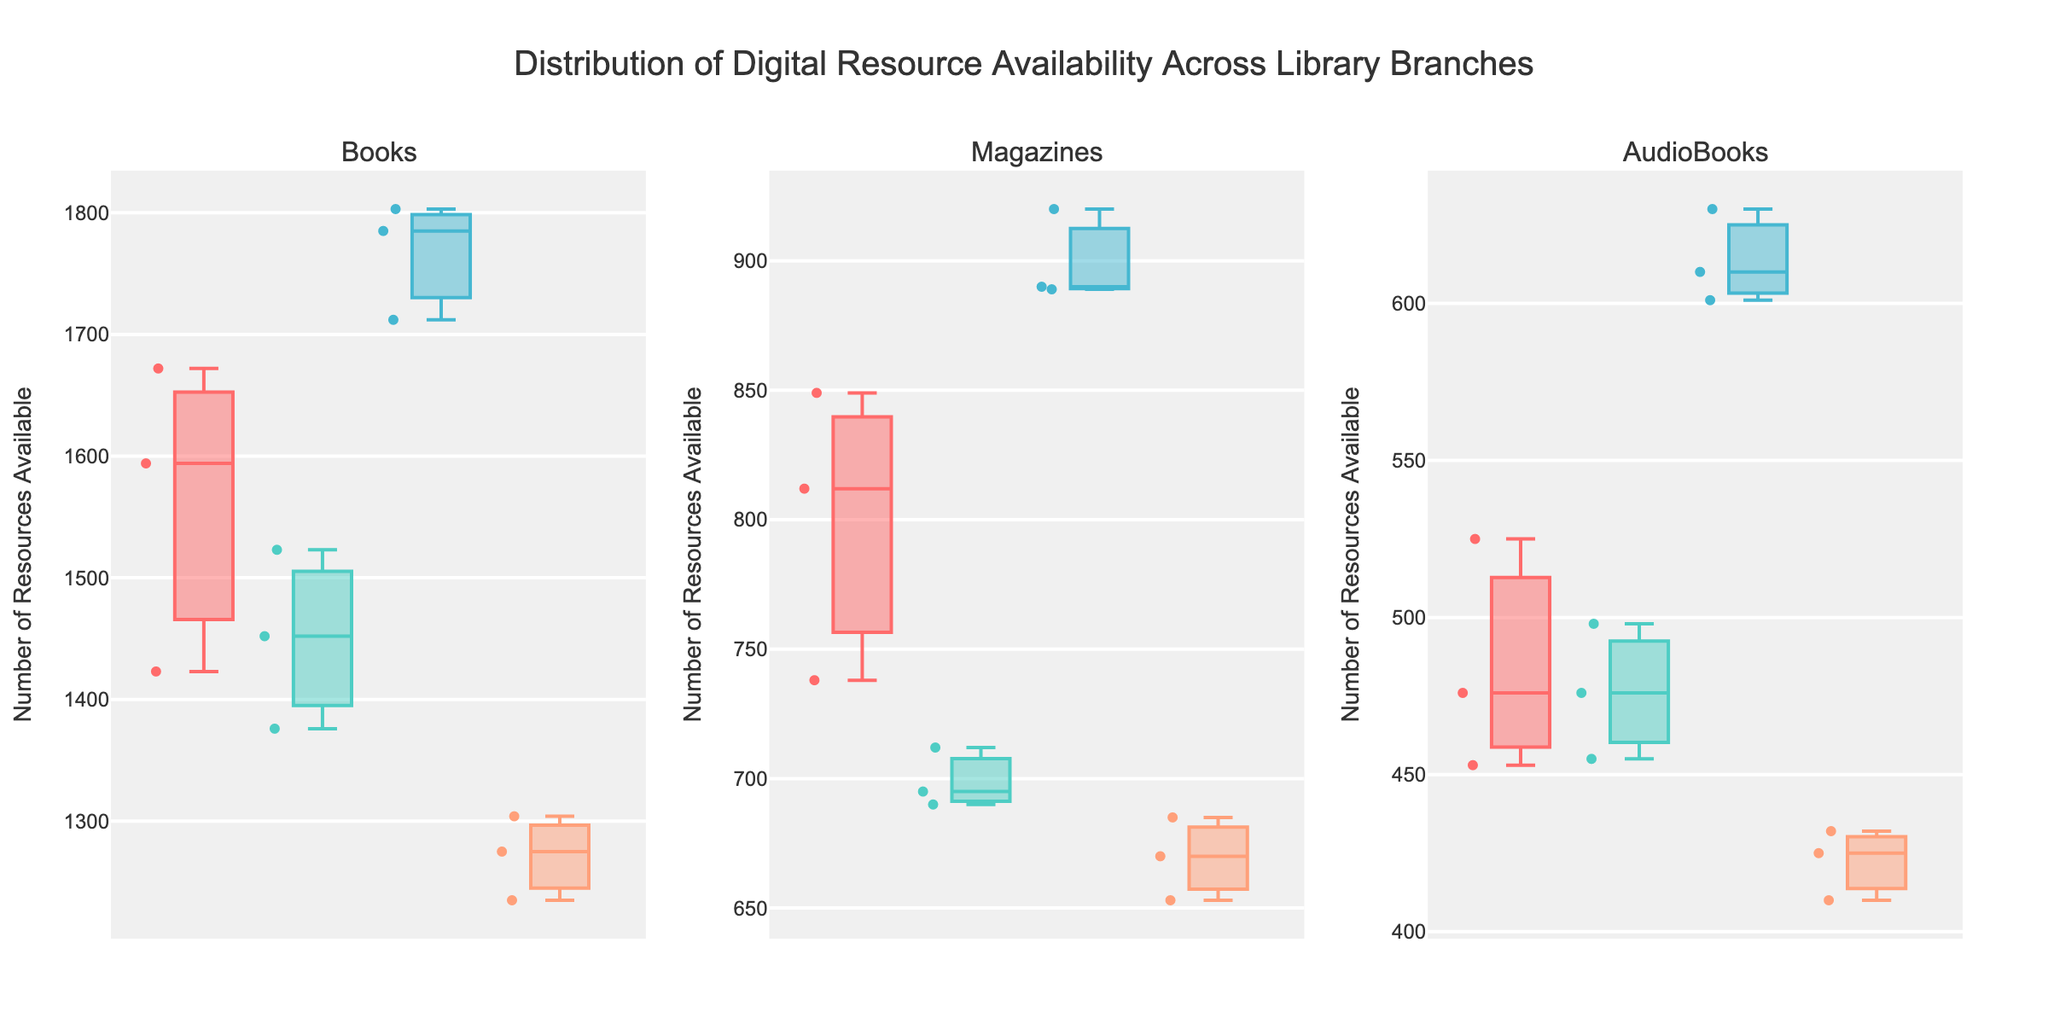What is the highest resource availability for books at the Downtown branch? Look at the Downtown branch's box plot in the "Books" subplot. The highest point is the maximum value of resource availability.
Answer: 1672 What is the median number of available magazines in the Uptown branch? Locate the Uptown branch in the "Magazines" subplot. The median is indicated by the line inside the box plot.
Answer: 695 Which branch has the widest range of audiobook availability? Compare the lengths of the whiskers in the "AudioBooks" subplot for each branch. The branch with the widest range has the longest whiskers.
Answer: Central Which branch has the highest median resource availability for books? Look at the line inside the boxes in the "Books" subplot. The tallest line represents the highest median value.
Answer: Central Compare the interquartile range (IQR) of magazines available between the Downtown and Eastside branches. Which branch has a larger IQR? The IQR is the height of the box. Compare the boxes in the "Magazines" subplot for Downtown and Eastside.
Answer: Downtown What can be inferred about resource availability variation for audiobooks in the Uptown branch compared to the Eastside branch? Look at the "AudioBooks" subplot. Compare the spread and distribution of the box plots for Uptown and Eastside. Uptown has a narrower spread indicating less variation.
Answer: Uptown has less variation Which branch's magazines have the smallest variability in availability? Compare the spread of the box plots in the "Magazines" subplot. The smallest spread represents the smallest variability.
Answer: Eastside What is the difference in the maximum resource availability between audiobooks in the Downtown and Central branches? Look at the maximum points (top whiskers) in the "AudioBooks" subplot for Downtown and Central. Subtract the maximum of Downtown from Central.
Answer: 630 - 525 = 105 Which resource type seems to have the most consistent availability across all branches? Compare the spreads (whisker lengths) in each subplot. The resource type with the smallest spread across all branches is the most consistent.
Answer: Magazines 